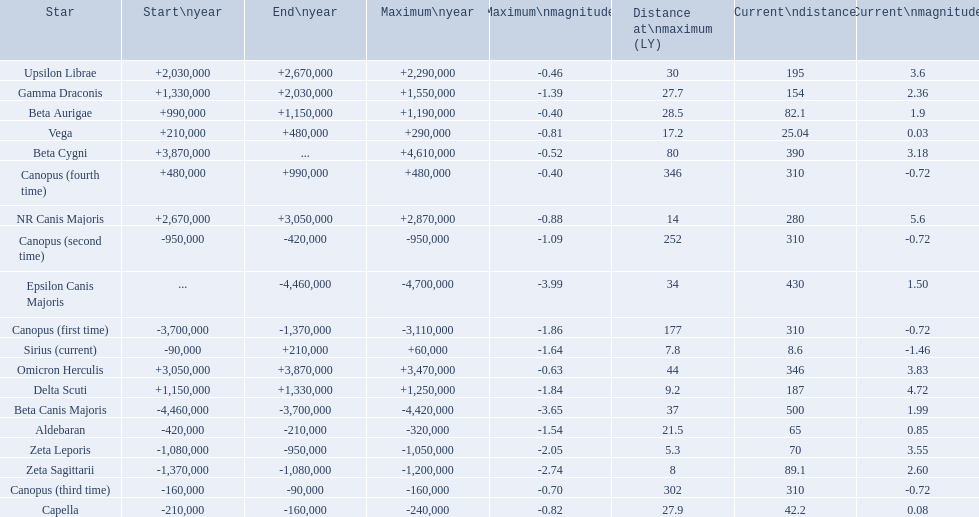What star has a a maximum magnitude of -0.63. Omicron Herculis. What star has a current distance of 390? Beta Cygni. 